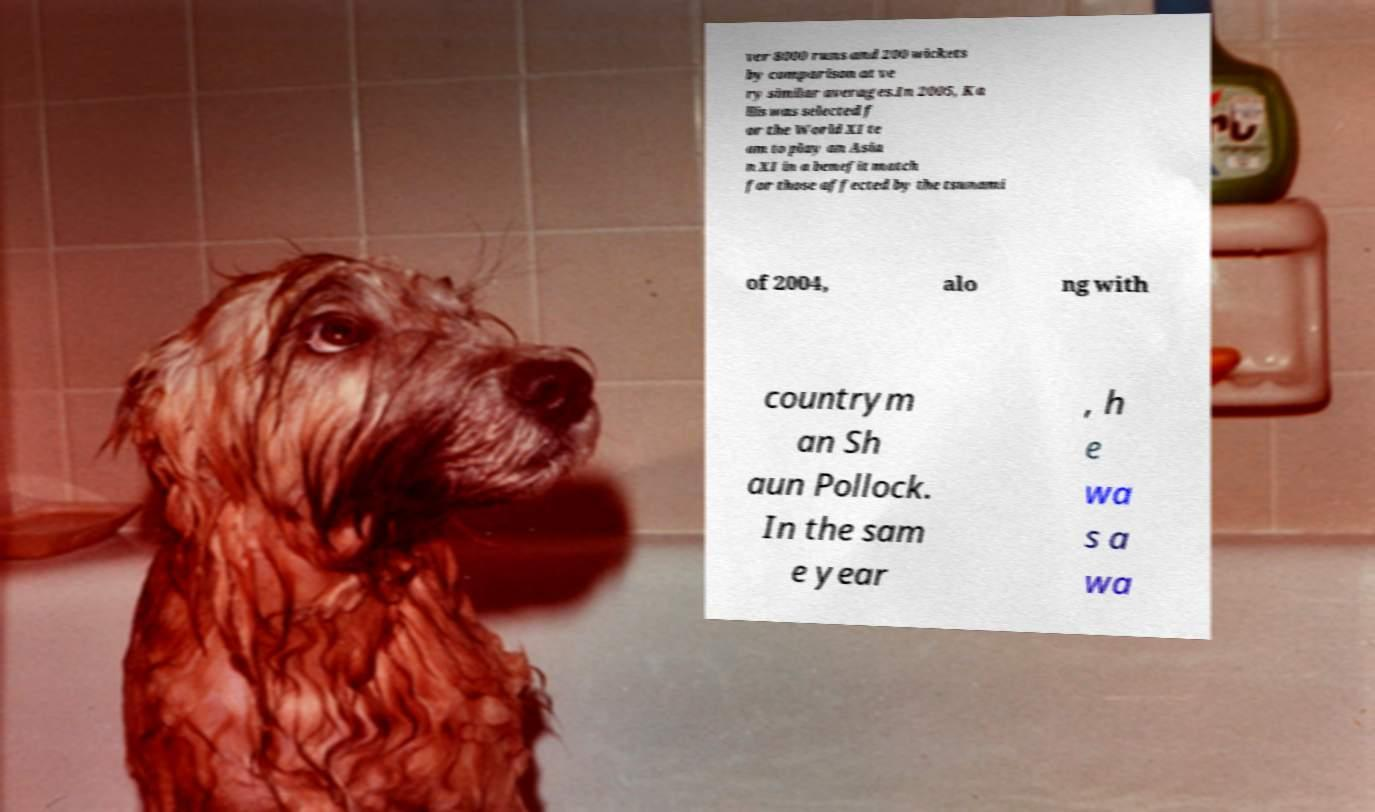Can you read and provide the text displayed in the image?This photo seems to have some interesting text. Can you extract and type it out for me? ver 8000 runs and 200 wickets by comparison at ve ry similar averages.In 2005, Ka llis was selected f or the World XI te am to play an Asia n XI in a benefit match for those affected by the tsunami of 2004, alo ng with countrym an Sh aun Pollock. In the sam e year , h e wa s a wa 